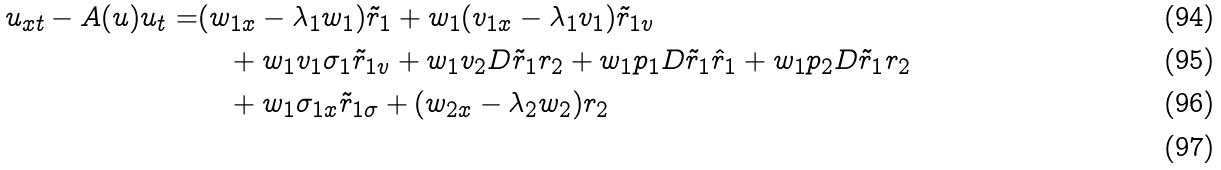Convert formula to latex. <formula><loc_0><loc_0><loc_500><loc_500>u _ { x t } - A ( u ) u _ { t } = & ( w _ { 1 x } - \lambda _ { 1 } w _ { 1 } ) \tilde { r } _ { 1 } + w _ { 1 } ( v _ { 1 x } - \lambda _ { 1 } v _ { 1 } ) \tilde { r } _ { 1 v } \\ & \quad + w _ { 1 } v _ { 1 } \sigma _ { 1 } \tilde { r } _ { 1 v } + w _ { 1 } v _ { 2 } D \tilde { r } _ { 1 } r _ { 2 } + w _ { 1 } p _ { 1 } D \tilde { r } _ { 1 } \hat { r } _ { 1 } + w _ { 1 } p _ { 2 } D \tilde { r } _ { 1 } r _ { 2 } \\ & \quad + w _ { 1 } \sigma _ { 1 x } \tilde { r } _ { 1 \sigma } + ( w _ { 2 x } - \lambda _ { 2 } w _ { 2 } ) r _ { 2 } \\</formula> 